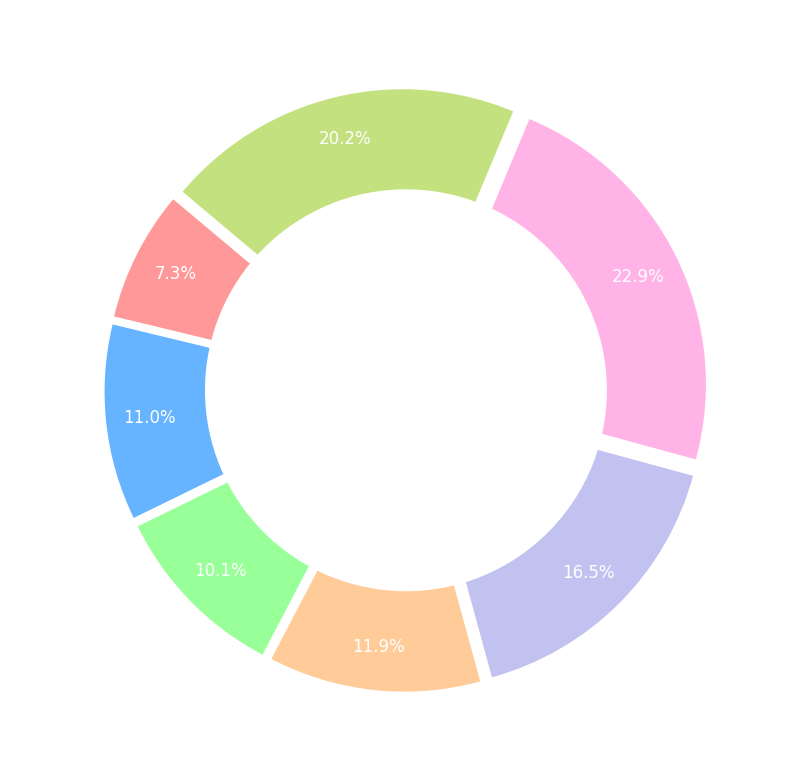Which day has the highest attendance? According to the figure, Saturday has the largest segment, indicating the highest attendance among all the days.
Answer: Saturday What is the combined attendance percentage for the weekend (Saturday and Sunday)? By looking at the figure, the percentage for Saturday is 33.3% and for Sunday is 29.3%. Adding these two percentages gives: 33.3% + 29.3% = 62.6%.
Answer: 62.6% How does the attendance on Friday compare to that on Wednesday? By observing the size of the segments, Friday has a larger segment than Wednesday. Converting the absolute numbers into attendance percentages, Friday is 24.0% and Wednesday is 14.7%. Thus, Friday has a higher attendance.
Answer: Friday What percentage of total attendance is during the weekdays (Monday to Friday)? Weekday percentages are Monday 10.7%, Tuesday 16.0%, Wednesday 14.7%, Thursday 17.3%, and Friday 24.0%. Adding these gives: 10.7% + 16.0% + 14.7% + 17.3% + 24.0% = 82.7%.
Answer: 82.7% Which color represents Thursday in the pie chart? Each segment of the pie chart is color-coded, and Thursday is represented by the fourth segment from the start angle, which is colored peach (#ffcc99).
Answer: Peach If the attendance on Sunday were to increase by 500, how would this affect its percentage share? The original Sunday attendance is 2200. New attendance would be 2200 + 500 = 2700. Total attendance would then be 1100 + 400 + 1200 + 1100 + 1300 + 1800 + 2700 = 9900. The new percentage for Sunday would be (2700 / 9900) * 100 ≈ 27.3%.
Answer: 27.3% What is the difference in attendance percentage between Tuesday and Thursday? Tuesday's percentage is 16.0% and Thursday's percentage is 17.3%. The difference between these percentages is: 17.3% - 16.0% = 1.3%.
Answer: 1.3% Which day is represented by the smallest segment in the pie chart? By observing the segments, Monday has the smallest segment, indicating the lowest attendance.
Answer: Monday 